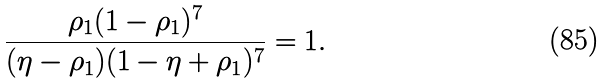<formula> <loc_0><loc_0><loc_500><loc_500>\frac { \rho _ { 1 } ( 1 - \rho _ { 1 } ) ^ { 7 } } { ( \eta - \rho _ { 1 } ) ( 1 - \eta + \rho _ { 1 } ) ^ { 7 } } = 1 .</formula> 